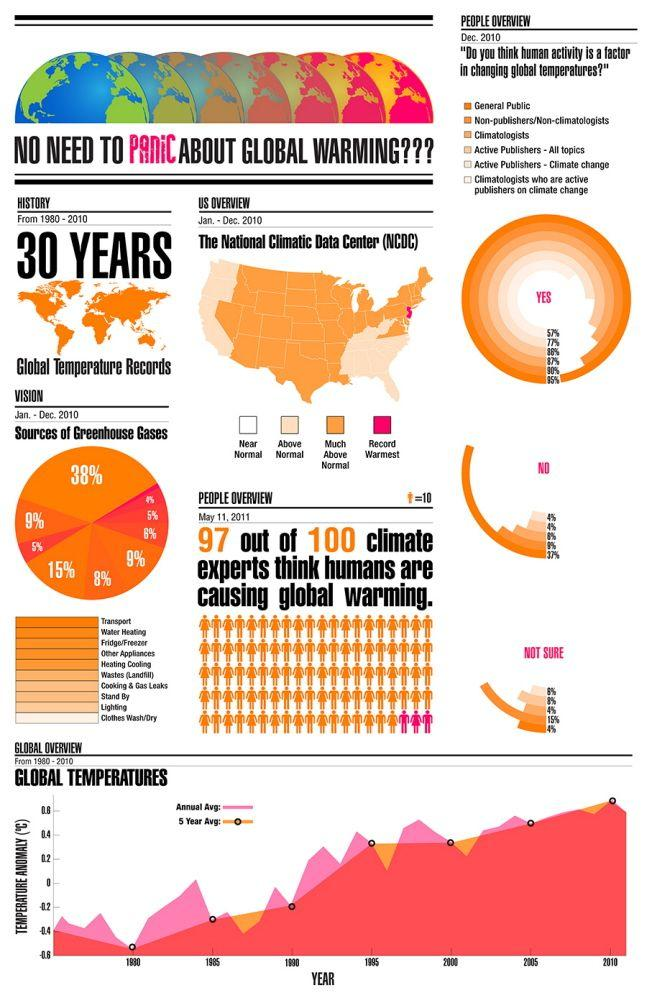Point out several critical features in this image. The largest source of greenhouse gases that correspond to 38% is transport. According to a survey conducted among the general public, a majority of 95% believe that human activity plays a role in altering global temperatures. According to a recent survey of climatologists, 4% are not sure if human activity causes a change in global temperatures. According to a survey of climate experts, a staggering 97% believe that human activities are the primary cause of global warming. A study found that only 8% of non-publishers believe that human activity does not contribute to the increase in global temperatures. 